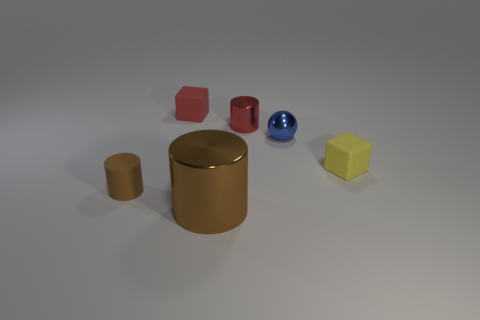What shapes are present in the image? There are multiple shapes visible including a sphere, a cube, a cylinder, and a couple of rectangular prisms in various colors. 